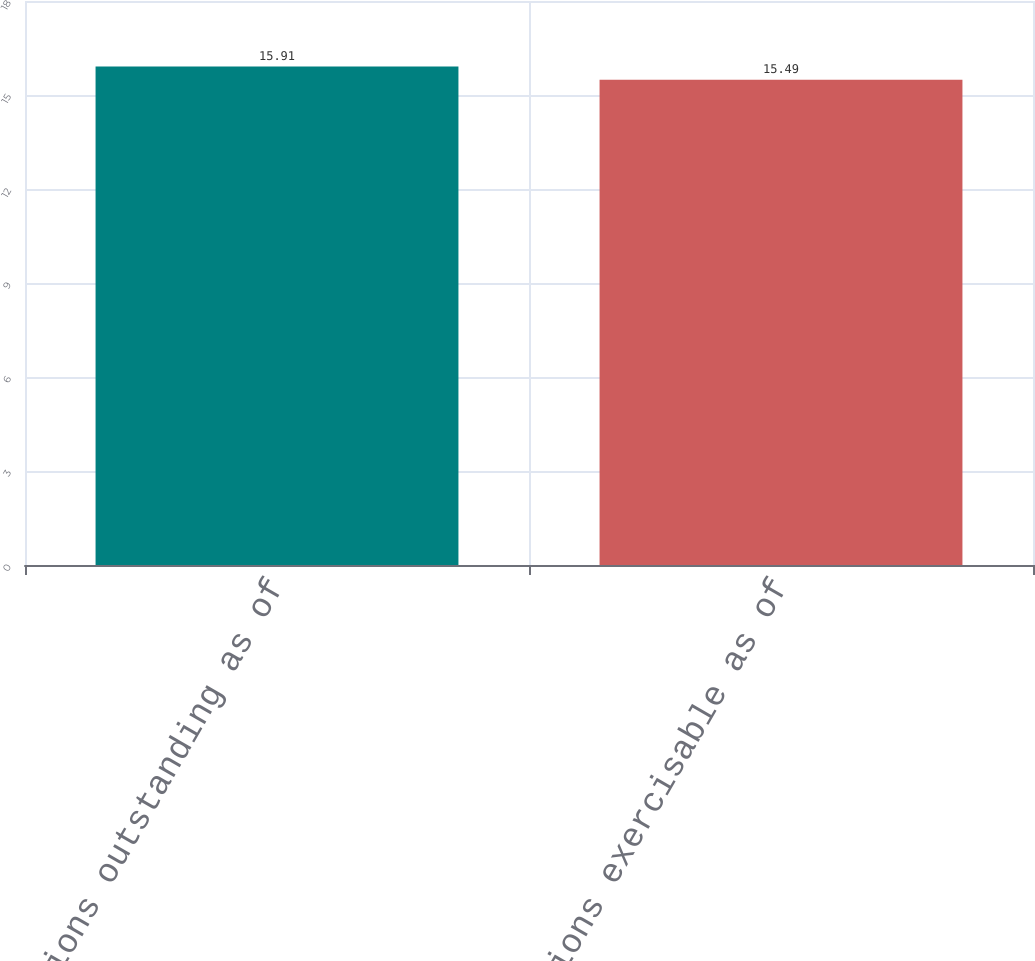Convert chart to OTSL. <chart><loc_0><loc_0><loc_500><loc_500><bar_chart><fcel>Options outstanding as of<fcel>Options exercisable as of<nl><fcel>15.91<fcel>15.49<nl></chart> 